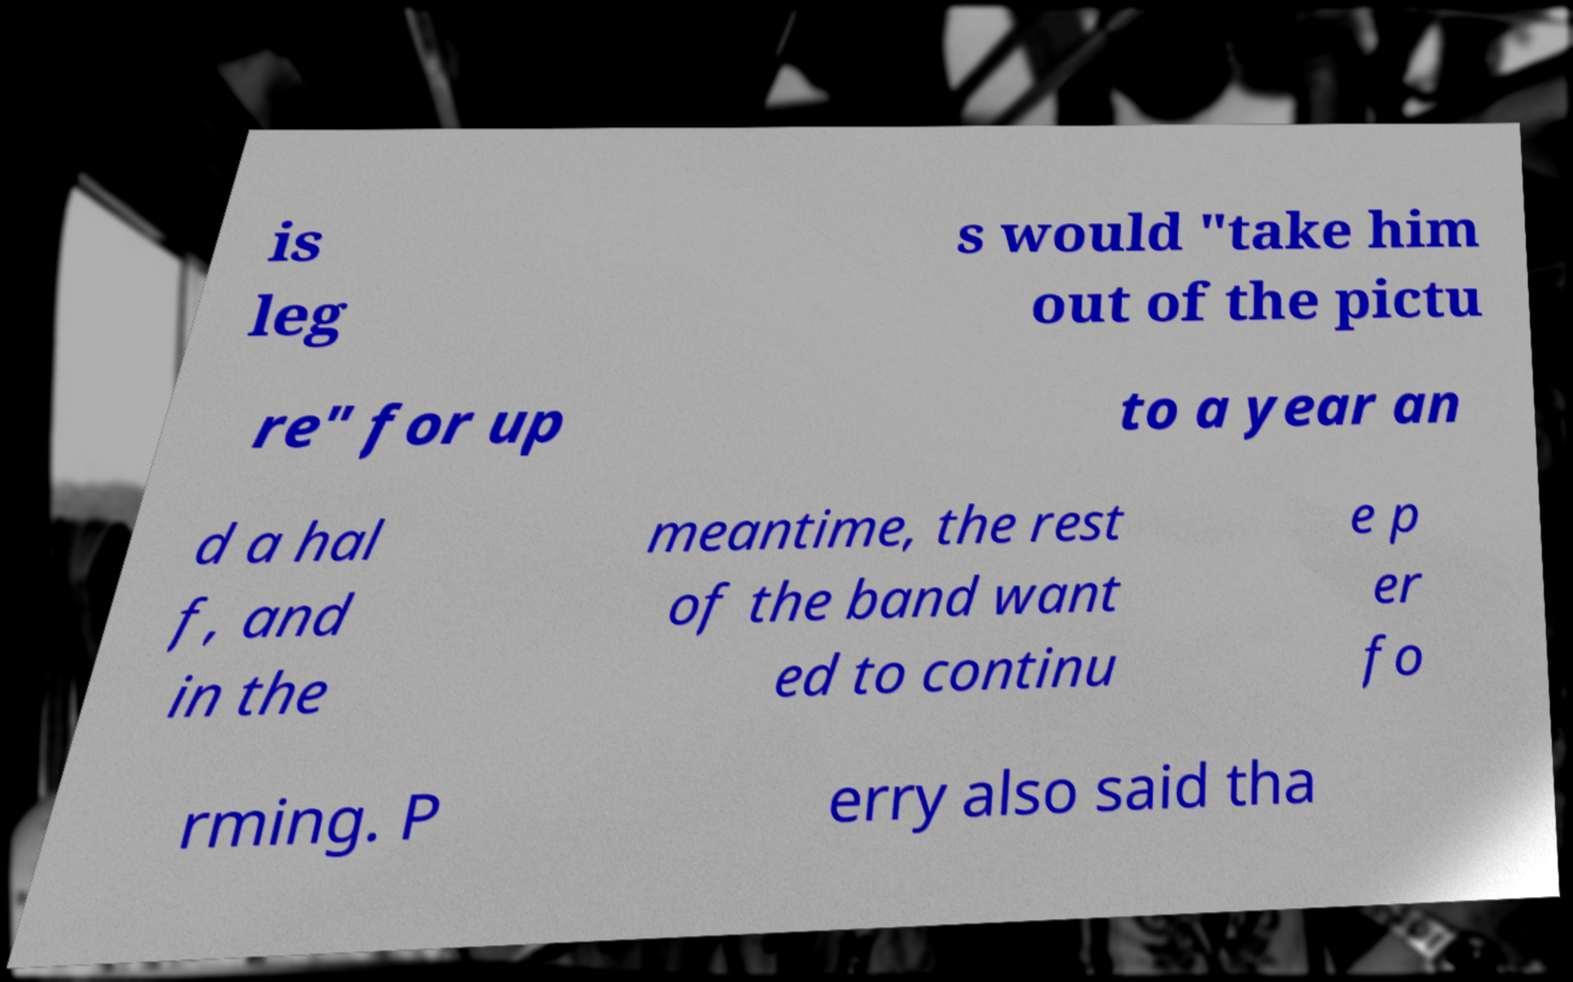There's text embedded in this image that I need extracted. Can you transcribe it verbatim? is leg s would "take him out of the pictu re" for up to a year an d a hal f, and in the meantime, the rest of the band want ed to continu e p er fo rming. P erry also said tha 